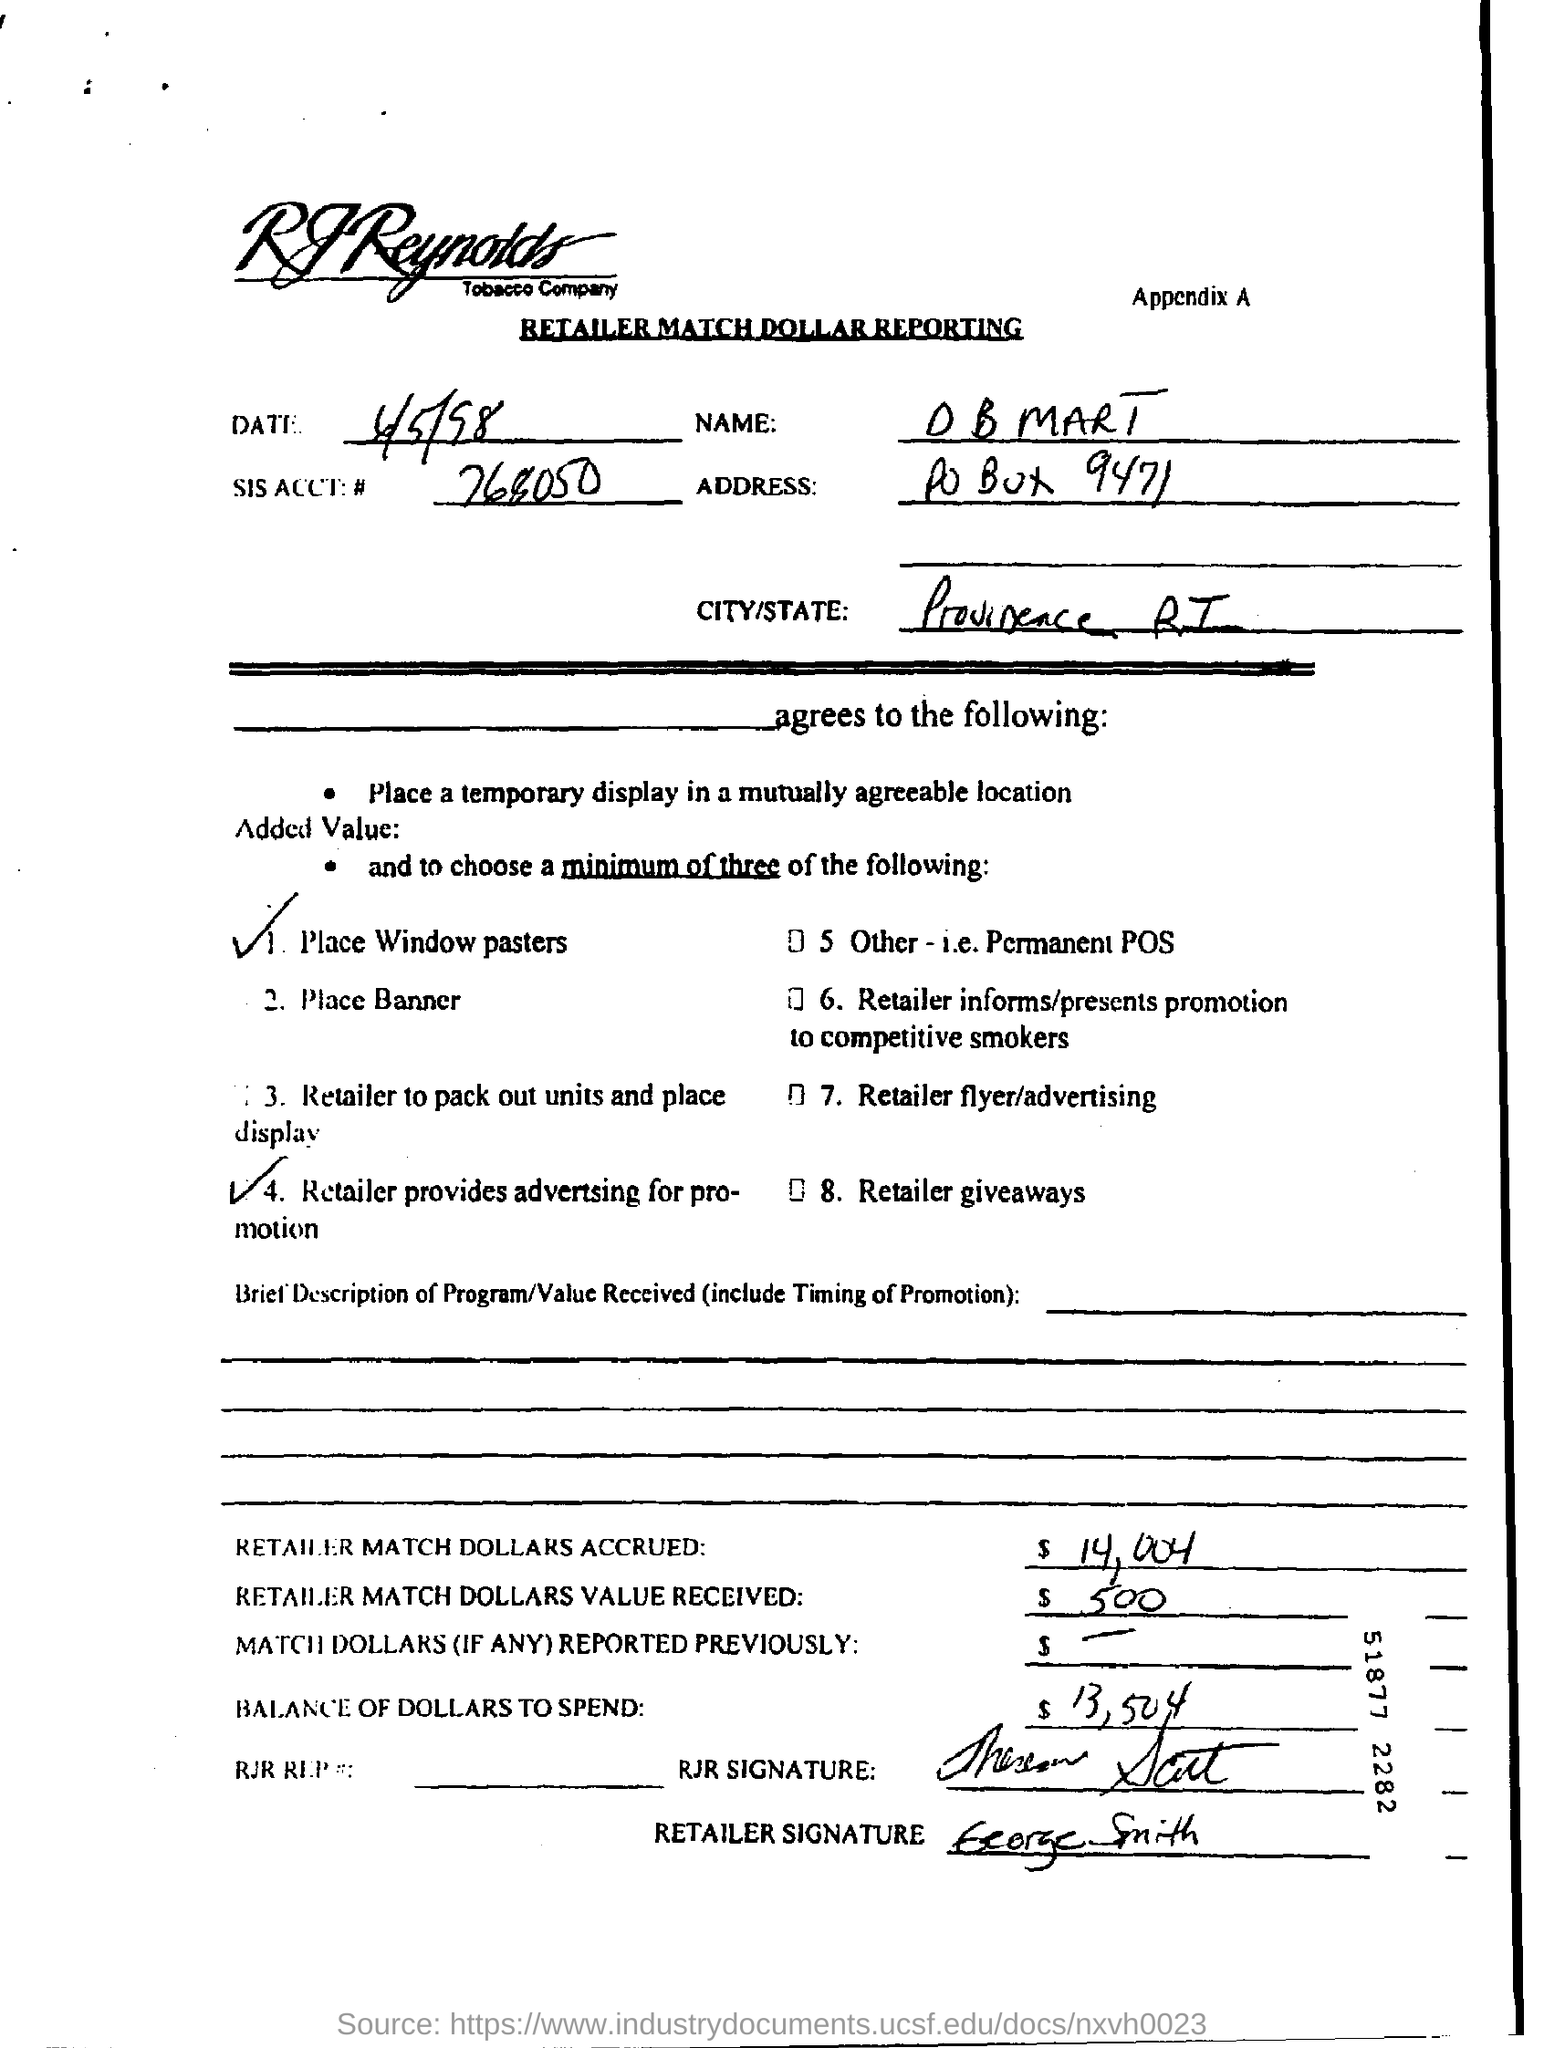What is name mentioned?
Make the answer very short. O B MART. 